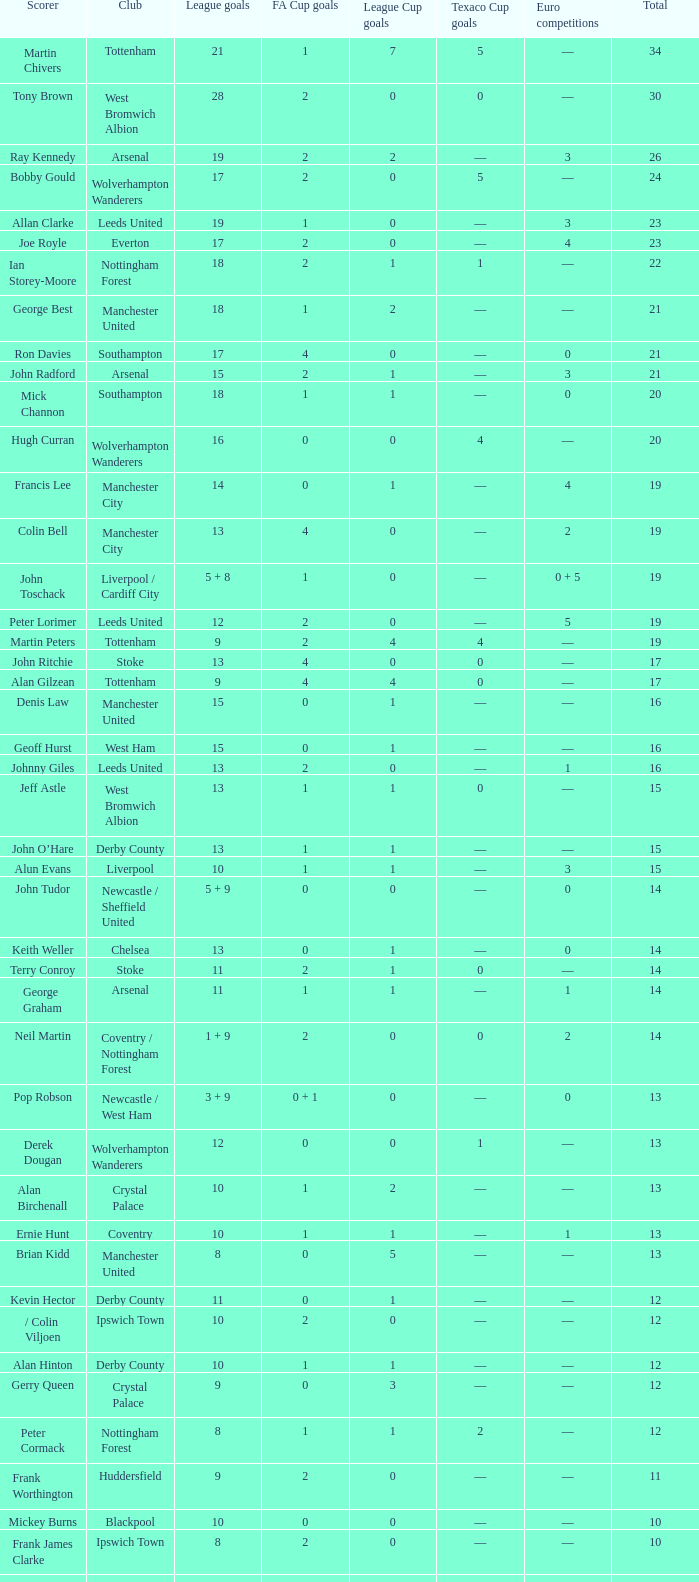What is fa cup goals, when european competitions is 1, and when league goals is 11? 1.0. 